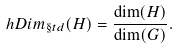Convert formula to latex. <formula><loc_0><loc_0><loc_500><loc_500>\ h D i m _ { \S t d } ( H ) = \frac { \dim ( H ) } { \dim ( G ) } .</formula> 